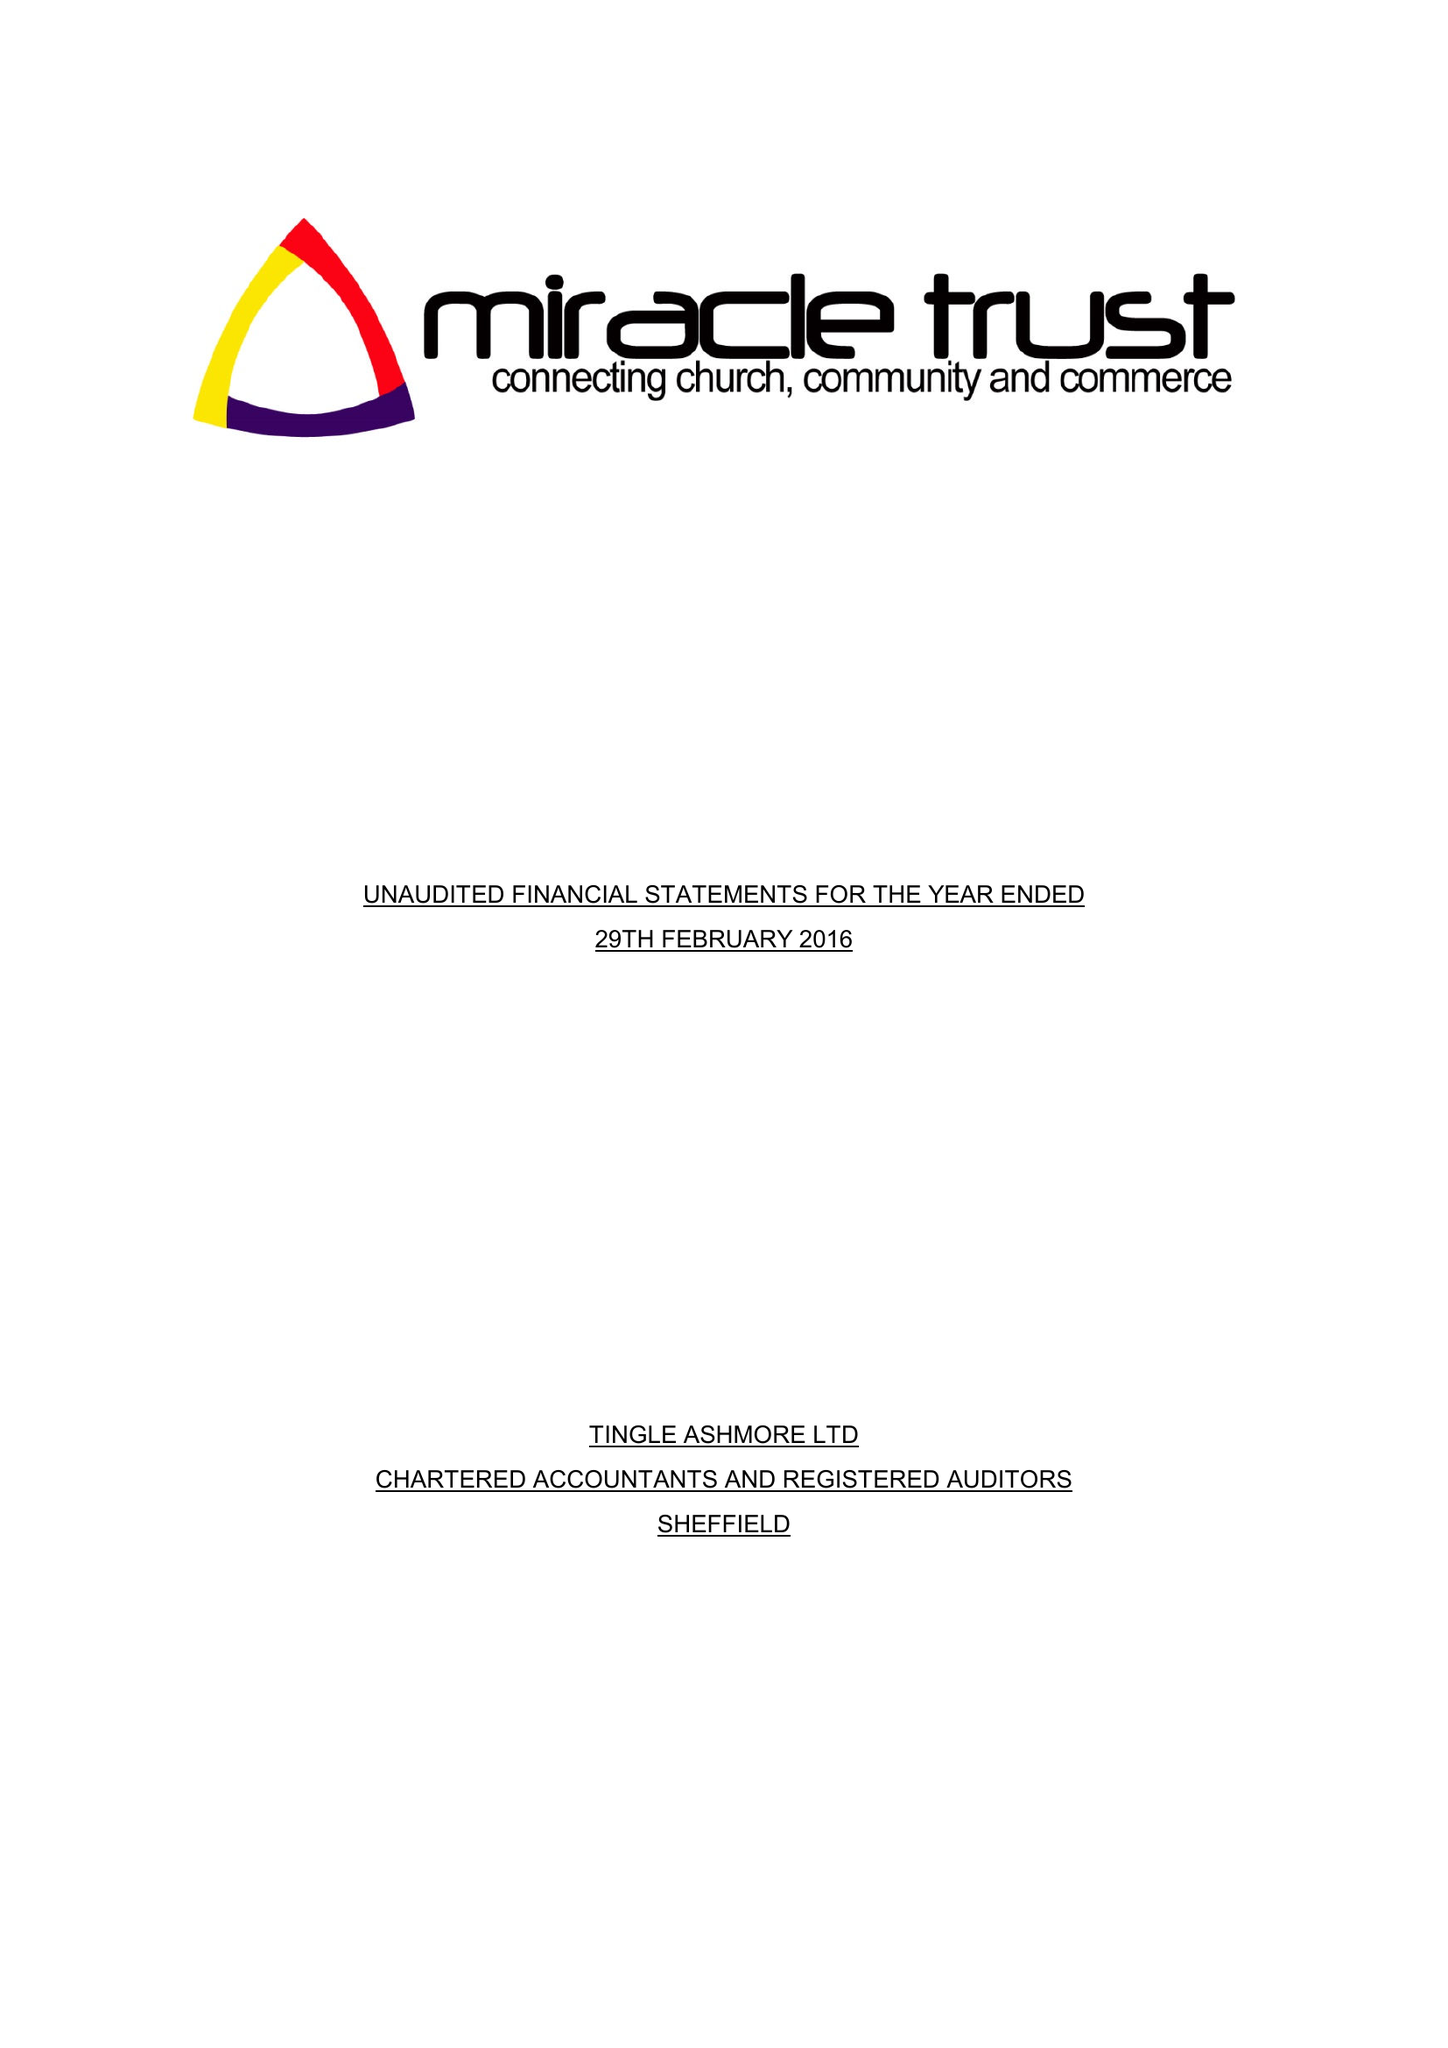What is the value for the report_date?
Answer the question using a single word or phrase. 2016-02-29 